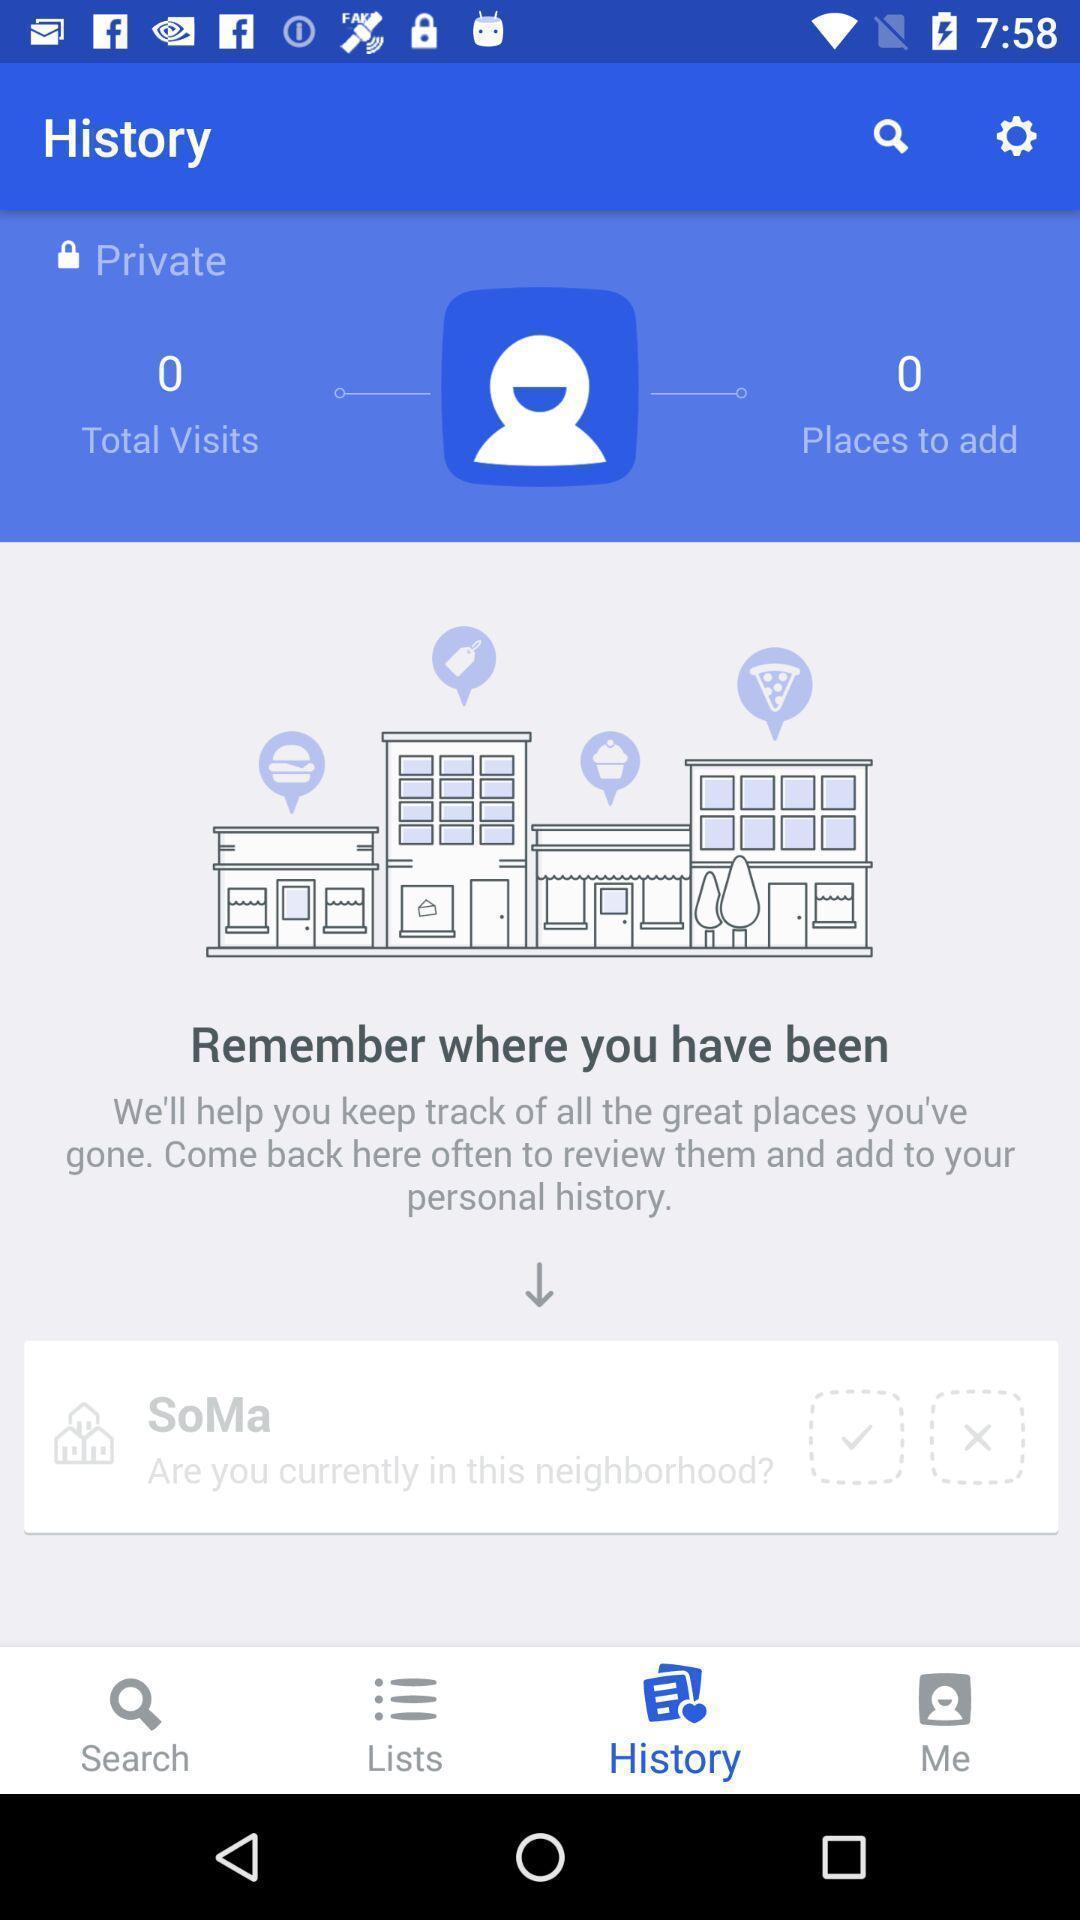Please provide a description for this image. Screen shows history page. 